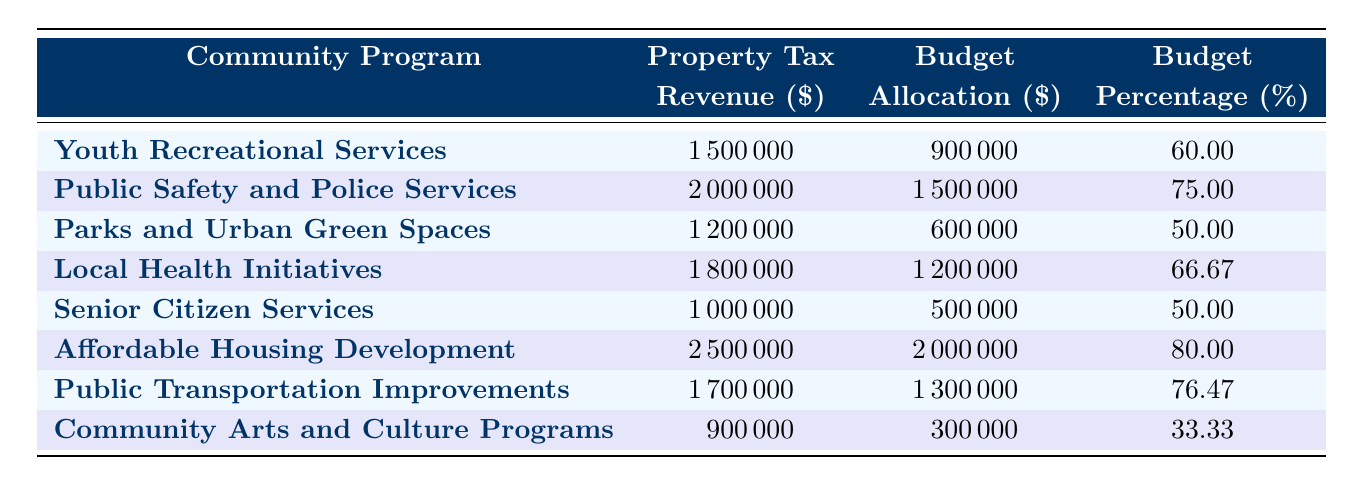What is the budget allocation for Youth Recreational Services? The table lists the budget allocation for Youth Recreational Services as 900,000.
Answer: 900000 Which community program has the highest property tax revenue? According to the table, Affordable Housing Development has the highest property tax revenue at 2,500,000.
Answer: 2500000 What is the percentage of budget allocation for Public Safety and Police Services? The table indicates that the percentage of budget allocation for Public Safety and Police Services is 75.
Answer: 75 How much more property tax revenue does Affordable Housing Development have compared to Community Arts and Culture Programs? Affordable Housing Development has 2,500,000 in property tax revenue while Community Arts and Culture Programs has 900,000. The difference is 2,500,000 - 900,000 = 1,600,000.
Answer: 1600000 What is the average percentage of budget allocation across all community programs? To find the average, sum the percentages (60 + 75 + 50 + 66.67 + 50 + 80 + 76.47 + 33.33) = 392.47, then divide by the number of programs (8): 392.47 / 8 = 49.06.
Answer: 49.06 Is the budget allocation for Senior Citizen Services equal to the property tax revenue? The budget allocation is 500,000 while the property tax revenue is 1,000,000; therefore, they are not equal.
Answer: No Which program has the lowest percentage of budget allocation? According to the table, Community Arts and Culture Programs has the lowest percentage of budget allocation at 33.33%.
Answer: 33.33 How much total property tax revenue is generated by all community programs combined? Adding the property tax revenues: (1,500,000 + 2,000,000 + 1,200,000 + 1,800,000 + 1,000,000 + 2,500,000 + 1,700,000 + 900,000) gives a total of 12,600,000.
Answer: 12600000 What is the budget allocation for Parks and Urban Green Spaces compared to the average percentage allocation of all programs? The budget allocation for Parks and Urban Green Spaces is 600,000; its percentage is 50%. The average percentage across all programs is calculated to be 49.06%. Since 50% is greater than 49.06%, it is above average.
Answer: Above average Does Local Health Initiatives receive more funding than Senior Citizen Services? Yes, Local Health Initiatives has a budget allocation of 1,200,000 which is greater than Senior Citizen Services' 500,000.
Answer: Yes 